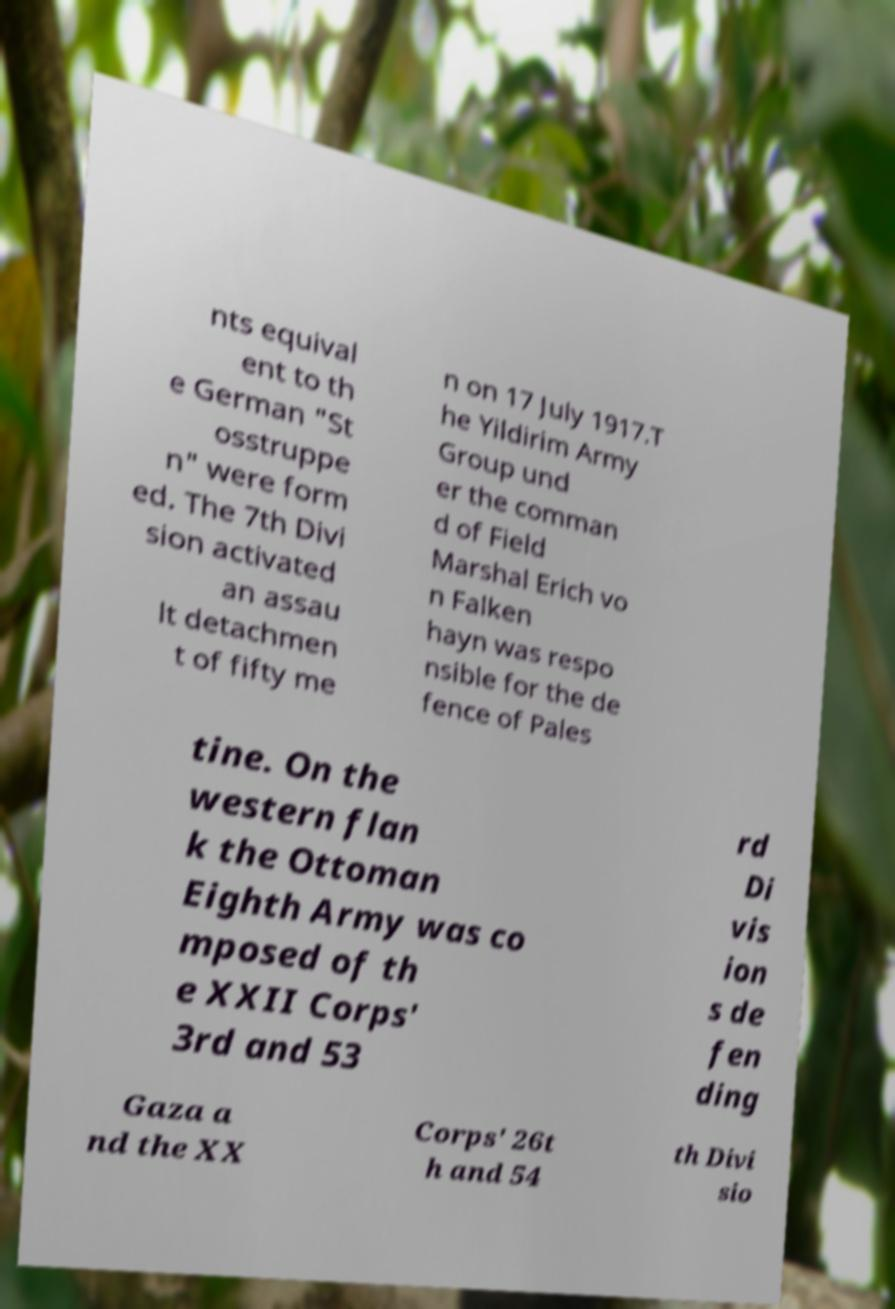Could you assist in decoding the text presented in this image and type it out clearly? nts equival ent to th e German "St osstruppe n" were form ed. The 7th Divi sion activated an assau lt detachmen t of fifty me n on 17 July 1917.T he Yildirim Army Group und er the comman d of Field Marshal Erich vo n Falken hayn was respo nsible for the de fence of Pales tine. On the western flan k the Ottoman Eighth Army was co mposed of th e XXII Corps' 3rd and 53 rd Di vis ion s de fen ding Gaza a nd the XX Corps' 26t h and 54 th Divi sio 